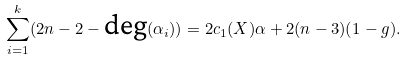<formula> <loc_0><loc_0><loc_500><loc_500>\sum _ { i = 1 } ^ { k } ( 2 n - 2 - \text {deg} ( \alpha _ { i } ) ) = 2 c _ { 1 } ( X ) \alpha + 2 ( n - 3 ) ( 1 - g ) .</formula> 